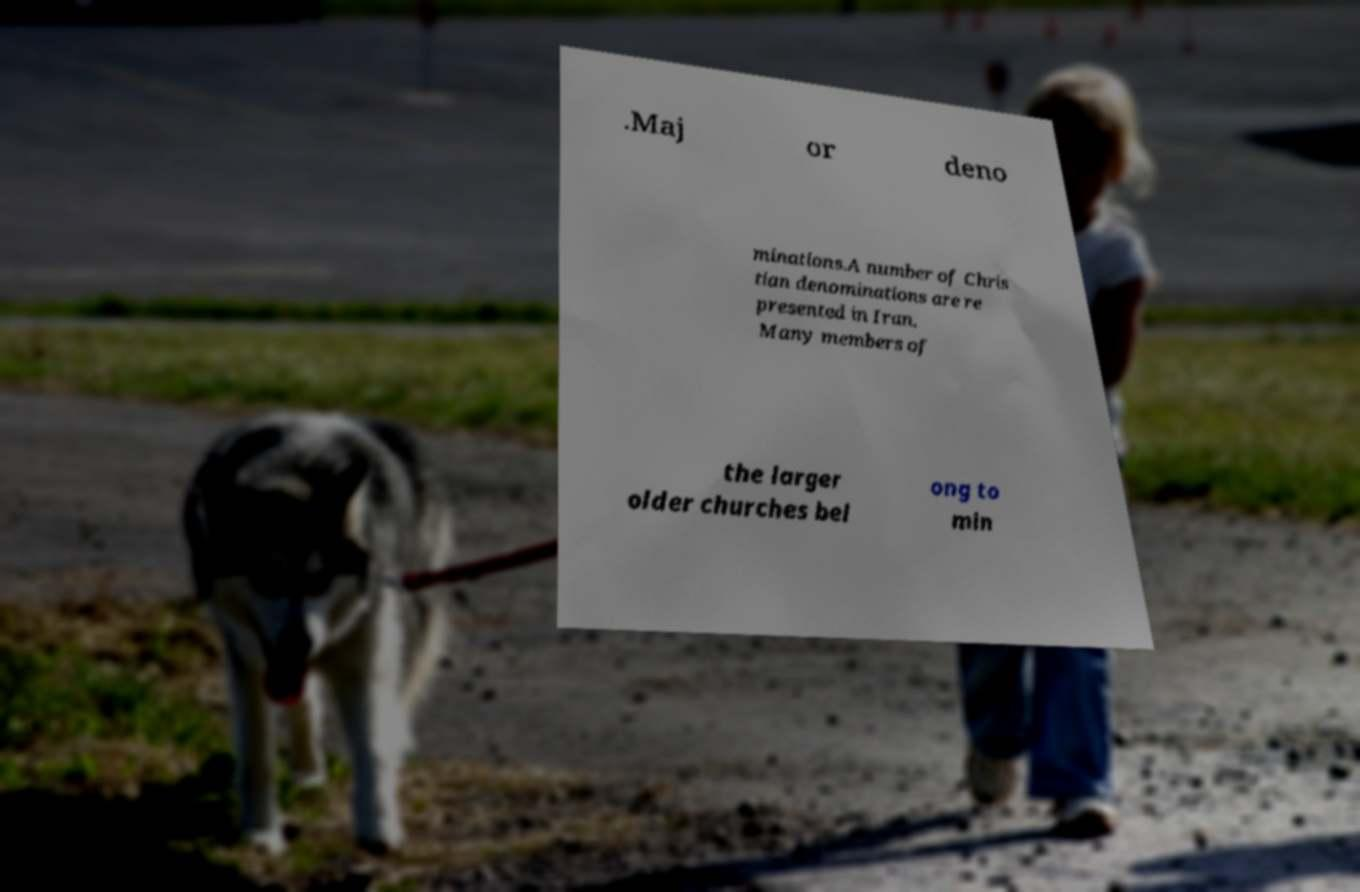Could you extract and type out the text from this image? .Maj or deno minations.A number of Chris tian denominations are re presented in Iran. Many members of the larger older churches bel ong to min 